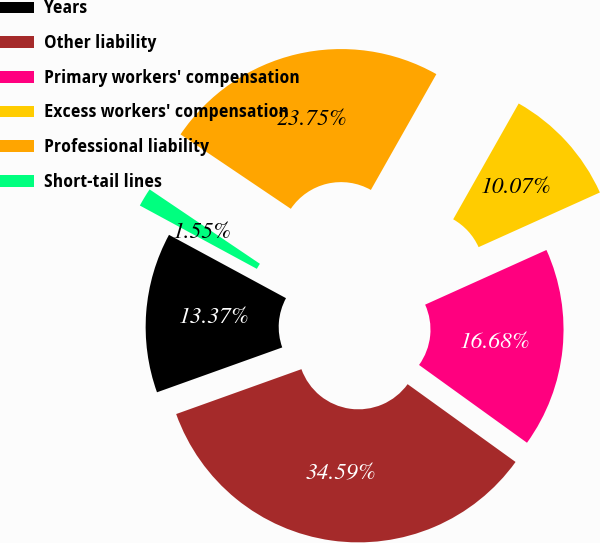Convert chart. <chart><loc_0><loc_0><loc_500><loc_500><pie_chart><fcel>Years<fcel>Other liability<fcel>Primary workers' compensation<fcel>Excess workers' compensation<fcel>Professional liability<fcel>Short-tail lines<nl><fcel>13.37%<fcel>34.59%<fcel>16.68%<fcel>10.07%<fcel>23.75%<fcel>1.55%<nl></chart> 